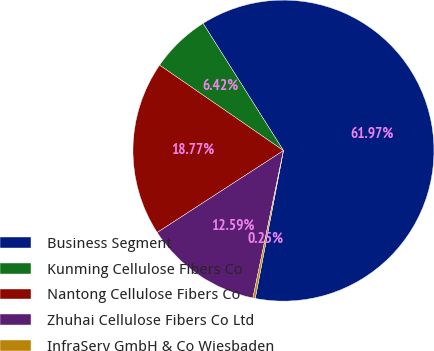Convert chart to OTSL. <chart><loc_0><loc_0><loc_500><loc_500><pie_chart><fcel>Business Segment<fcel>Kunming Cellulose Fibers Co<fcel>Nantong Cellulose Fibers Co<fcel>Zhuhai Cellulose Fibers Co Ltd<fcel>InfraServ GmbH & Co Wiesbaden<nl><fcel>61.98%<fcel>6.42%<fcel>18.77%<fcel>12.59%<fcel>0.25%<nl></chart> 